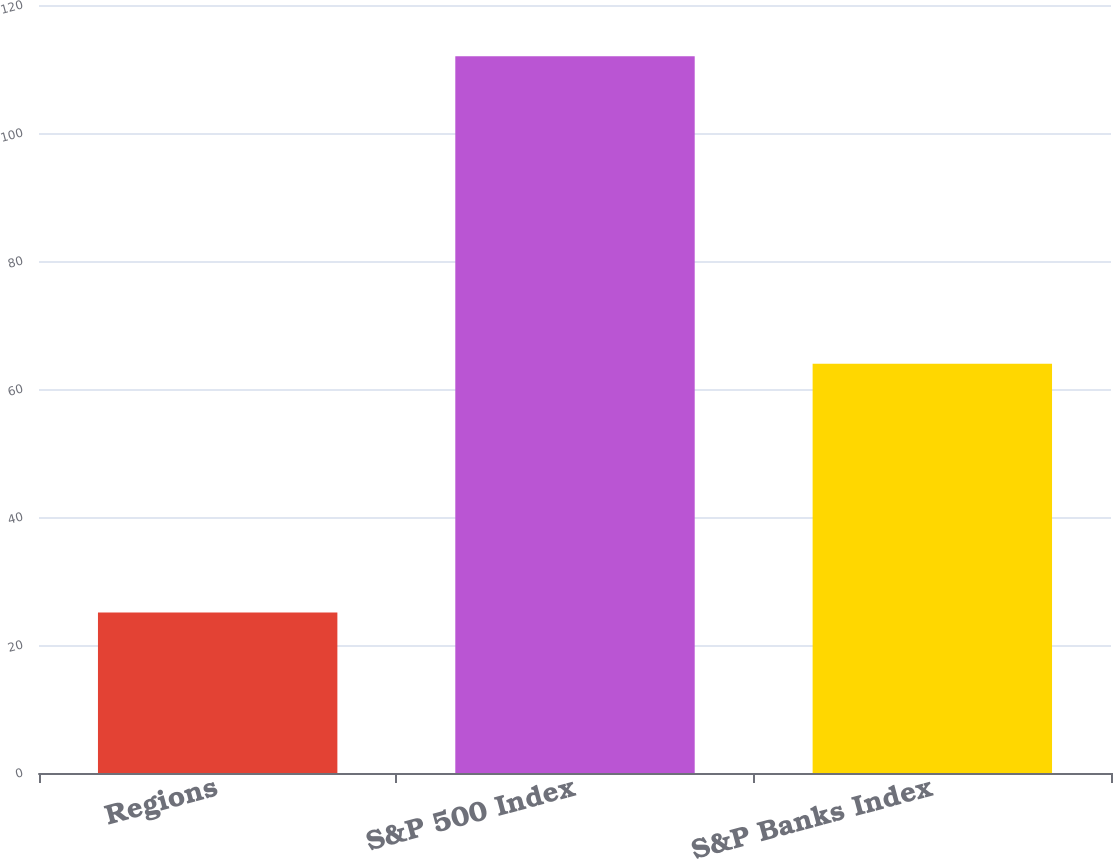Convert chart. <chart><loc_0><loc_0><loc_500><loc_500><bar_chart><fcel>Regions<fcel>S&P 500 Index<fcel>S&P Banks Index<nl><fcel>25.07<fcel>111.99<fcel>63.96<nl></chart> 